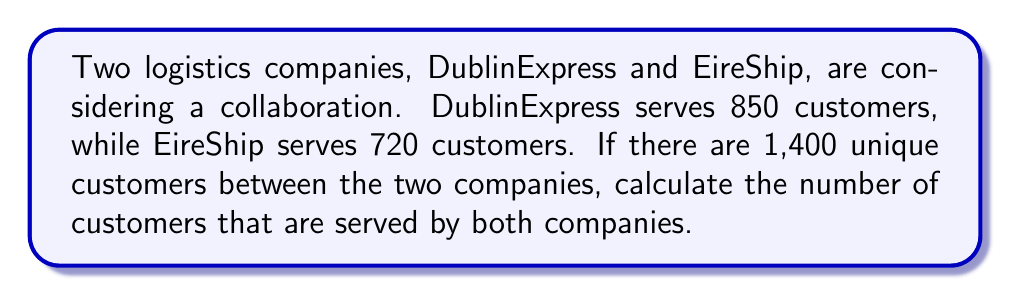Could you help me with this problem? To solve this problem, we'll use set theory concepts, specifically the principle of inclusion-exclusion.

Let's define our sets:
$A$: customers of DublinExpress
$B$: customers of EireShip

We know:
$|A| = 850$ (DublinExpress customers)
$|B| = 720$ (EireShip customers)
$|A \cup B| = 1400$ (Total unique customers)

We need to find $|A \cap B|$ (customers served by both companies).

The principle of inclusion-exclusion states:
$$|A \cup B| = |A| + |B| - |A \cap B|$$

Rearranging this equation to solve for $|A \cap B|$:
$$|A \cap B| = |A| + |B| - |A \cup B|$$

Now, let's substitute the known values:
$$|A \cap B| = 850 + 720 - 1400$$
$$|A \cap B| = 1570 - 1400$$
$$|A \cap B| = 170$$

Therefore, 170 customers are served by both companies.
Answer: 170 customers 